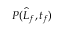Convert formula to latex. <formula><loc_0><loc_0><loc_500><loc_500>P ( \widehat { L } _ { f } , t _ { f } )</formula> 